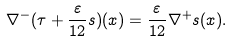Convert formula to latex. <formula><loc_0><loc_0><loc_500><loc_500>\nabla ^ { - } ( \tau + \frac { \varepsilon } { 1 2 } s ) ( x ) = \frac { \varepsilon } { 1 2 } \nabla ^ { + } s ( x ) .</formula> 